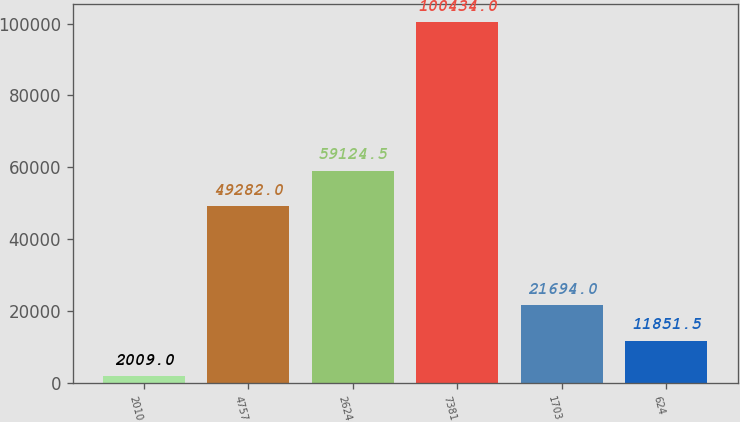<chart> <loc_0><loc_0><loc_500><loc_500><bar_chart><fcel>2010<fcel>4757<fcel>2624<fcel>7381<fcel>1703<fcel>624<nl><fcel>2009<fcel>49282<fcel>59124.5<fcel>100434<fcel>21694<fcel>11851.5<nl></chart> 